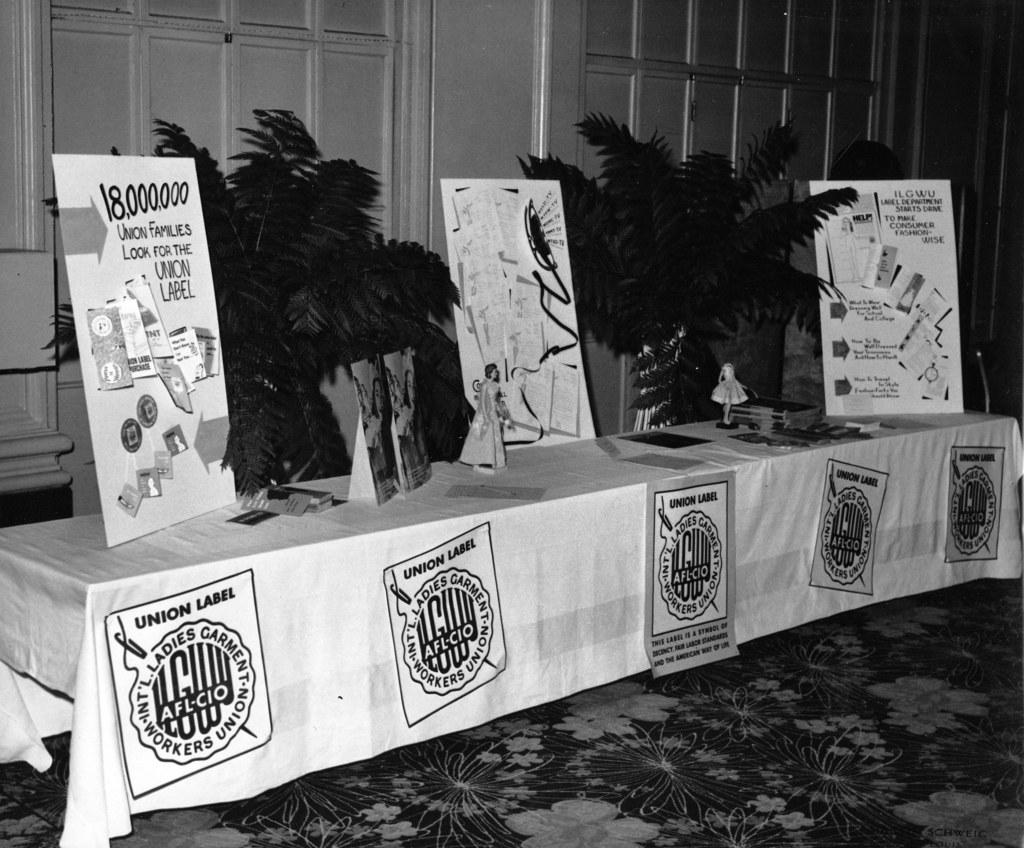What does the poster board ask union families to look for?
Keep it short and to the point. Union label. How many families?
Ensure brevity in your answer.  18,000,000. 